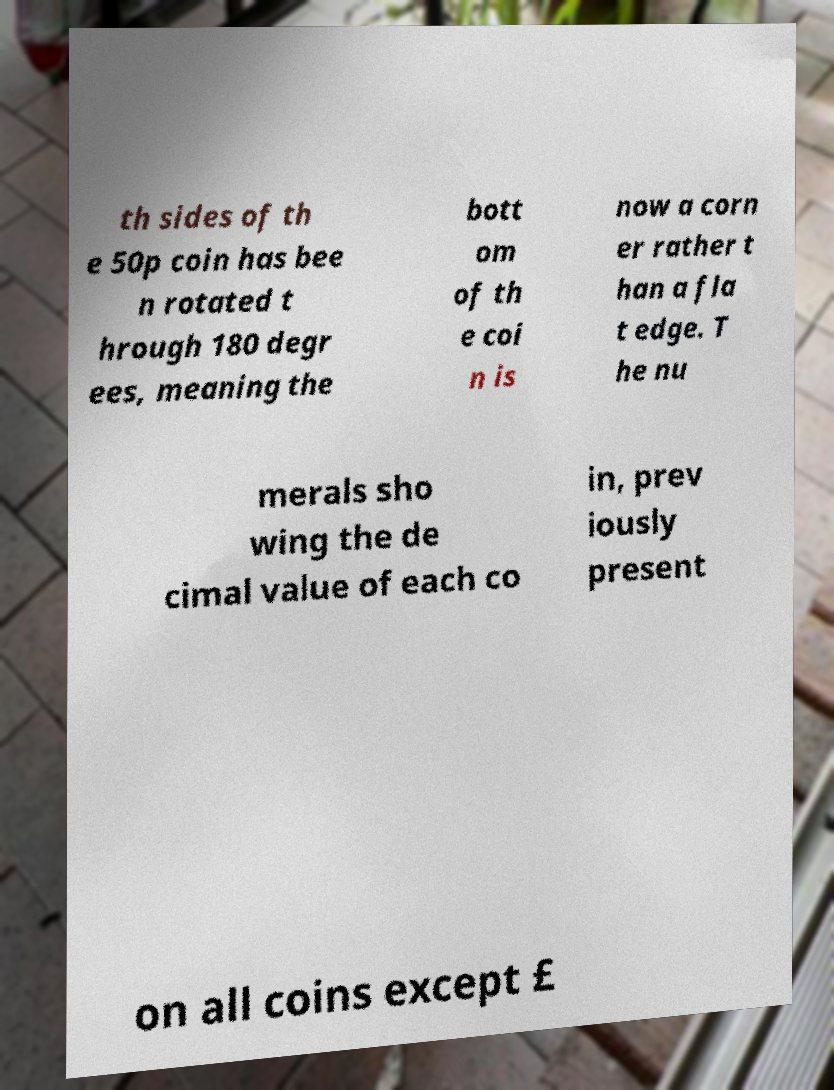Could you assist in decoding the text presented in this image and type it out clearly? th sides of th e 50p coin has bee n rotated t hrough 180 degr ees, meaning the bott om of th e coi n is now a corn er rather t han a fla t edge. T he nu merals sho wing the de cimal value of each co in, prev iously present on all coins except £ 